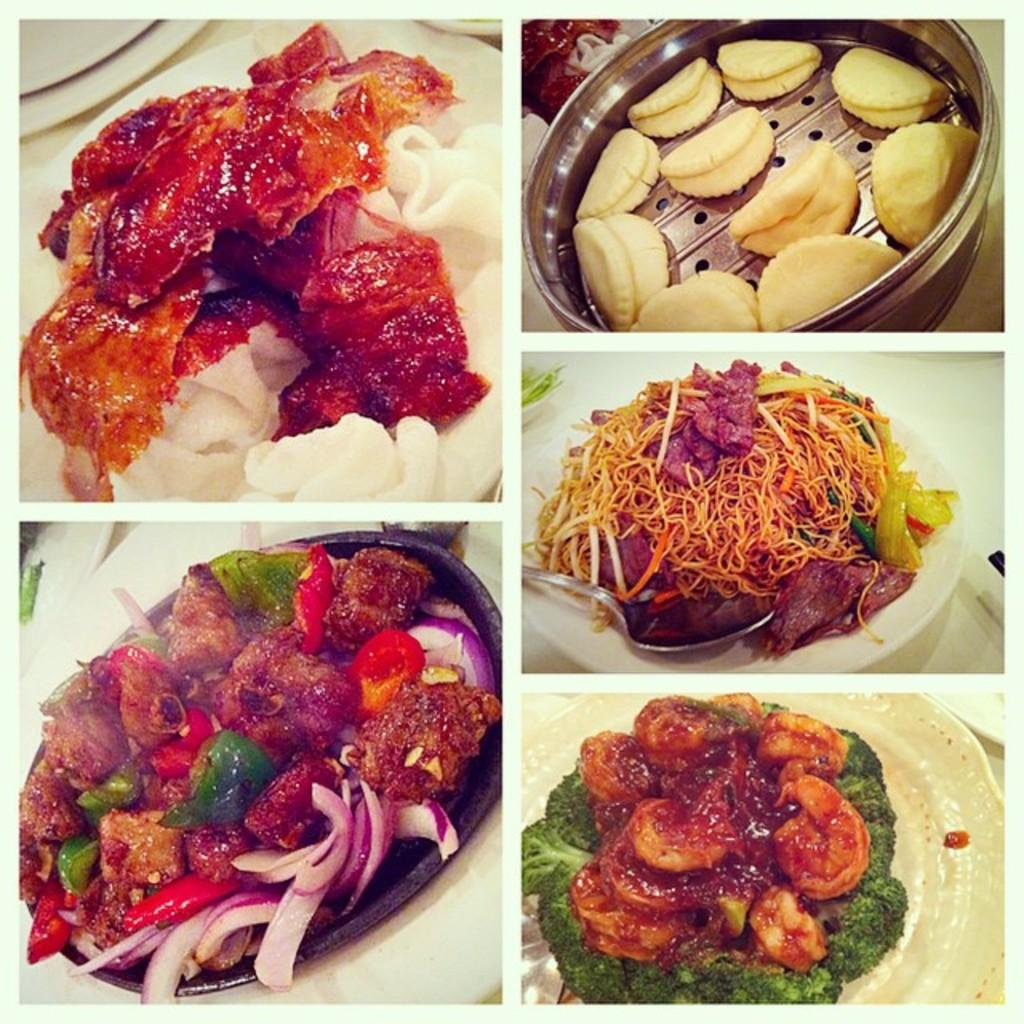What is present in the containers in the image? There is food in the containers in the image. What type of force is being applied to the containers in the image? There is no indication of any force being applied to the containers in the image. 